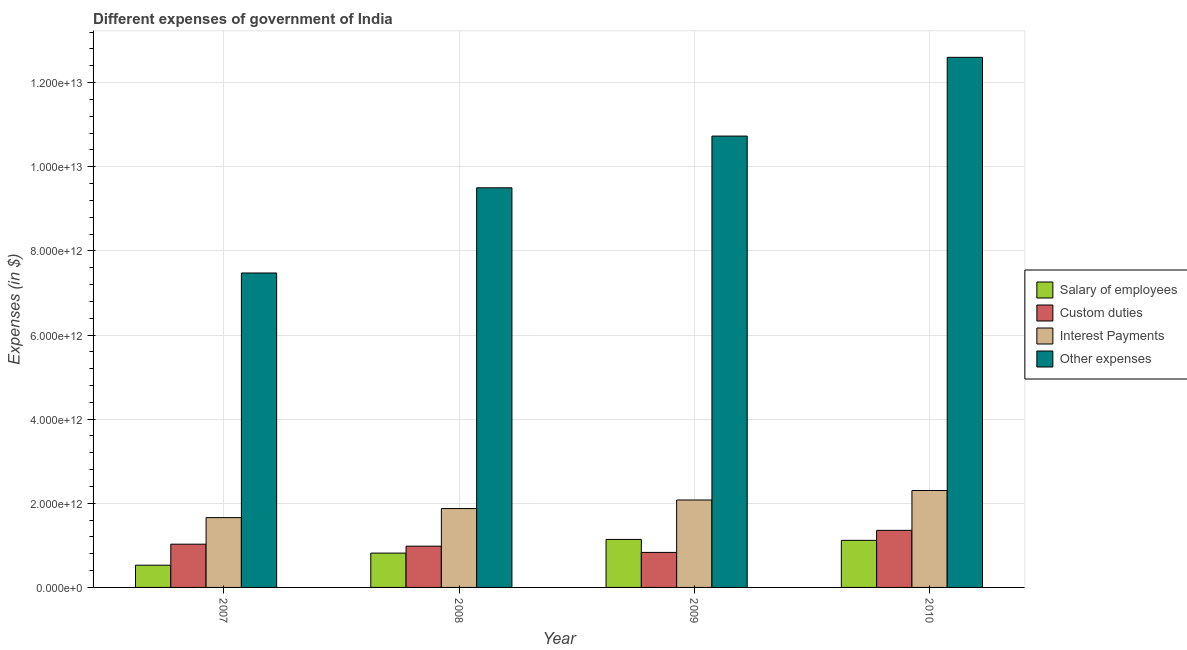How many different coloured bars are there?
Offer a very short reply. 4. How many groups of bars are there?
Your response must be concise. 4. How many bars are there on the 1st tick from the right?
Keep it short and to the point. 4. What is the label of the 4th group of bars from the left?
Provide a short and direct response. 2010. What is the amount spent on salary of employees in 2007?
Ensure brevity in your answer.  5.28e+11. Across all years, what is the maximum amount spent on other expenses?
Make the answer very short. 1.26e+13. Across all years, what is the minimum amount spent on salary of employees?
Your answer should be compact. 5.28e+11. In which year was the amount spent on salary of employees maximum?
Give a very brief answer. 2009. What is the total amount spent on other expenses in the graph?
Offer a terse response. 4.03e+13. What is the difference between the amount spent on interest payments in 2007 and that in 2008?
Offer a terse response. -2.15e+11. What is the difference between the amount spent on other expenses in 2008 and the amount spent on interest payments in 2009?
Provide a short and direct response. -1.23e+12. What is the average amount spent on salary of employees per year?
Offer a very short reply. 9.01e+11. In how many years, is the amount spent on interest payments greater than 7600000000000 $?
Offer a terse response. 0. What is the ratio of the amount spent on other expenses in 2007 to that in 2009?
Provide a short and direct response. 0.7. Is the difference between the amount spent on salary of employees in 2008 and 2009 greater than the difference between the amount spent on custom duties in 2008 and 2009?
Offer a very short reply. No. What is the difference between the highest and the second highest amount spent on other expenses?
Keep it short and to the point. 1.87e+12. What is the difference between the highest and the lowest amount spent on interest payments?
Offer a very short reply. 6.44e+11. In how many years, is the amount spent on custom duties greater than the average amount spent on custom duties taken over all years?
Keep it short and to the point. 1. Is it the case that in every year, the sum of the amount spent on interest payments and amount spent on other expenses is greater than the sum of amount spent on salary of employees and amount spent on custom duties?
Ensure brevity in your answer.  Yes. What does the 4th bar from the left in 2007 represents?
Your answer should be compact. Other expenses. What does the 1st bar from the right in 2009 represents?
Keep it short and to the point. Other expenses. Is it the case that in every year, the sum of the amount spent on salary of employees and amount spent on custom duties is greater than the amount spent on interest payments?
Your answer should be very brief. No. Are all the bars in the graph horizontal?
Provide a short and direct response. No. How many years are there in the graph?
Ensure brevity in your answer.  4. What is the difference between two consecutive major ticks on the Y-axis?
Provide a succinct answer. 2.00e+12. What is the title of the graph?
Provide a short and direct response. Different expenses of government of India. Does "Third 20% of population" appear as one of the legend labels in the graph?
Your answer should be very brief. No. What is the label or title of the Y-axis?
Give a very brief answer. Expenses (in $). What is the Expenses (in $) of Salary of employees in 2007?
Ensure brevity in your answer.  5.28e+11. What is the Expenses (in $) of Custom duties in 2007?
Your answer should be very brief. 1.03e+12. What is the Expenses (in $) in Interest Payments in 2007?
Offer a very short reply. 1.66e+12. What is the Expenses (in $) in Other expenses in 2007?
Offer a terse response. 7.47e+12. What is the Expenses (in $) of Salary of employees in 2008?
Give a very brief answer. 8.16e+11. What is the Expenses (in $) in Custom duties in 2008?
Offer a very short reply. 9.81e+11. What is the Expenses (in $) of Interest Payments in 2008?
Keep it short and to the point. 1.87e+12. What is the Expenses (in $) of Other expenses in 2008?
Provide a short and direct response. 9.50e+12. What is the Expenses (in $) of Salary of employees in 2009?
Your answer should be compact. 1.14e+12. What is the Expenses (in $) of Custom duties in 2009?
Make the answer very short. 8.32e+11. What is the Expenses (in $) in Interest Payments in 2009?
Your answer should be compact. 2.08e+12. What is the Expenses (in $) of Other expenses in 2009?
Make the answer very short. 1.07e+13. What is the Expenses (in $) in Salary of employees in 2010?
Provide a succinct answer. 1.12e+12. What is the Expenses (in $) in Custom duties in 2010?
Offer a very short reply. 1.36e+12. What is the Expenses (in $) of Interest Payments in 2010?
Ensure brevity in your answer.  2.30e+12. What is the Expenses (in $) in Other expenses in 2010?
Ensure brevity in your answer.  1.26e+13. Across all years, what is the maximum Expenses (in $) of Salary of employees?
Offer a very short reply. 1.14e+12. Across all years, what is the maximum Expenses (in $) of Custom duties?
Your answer should be very brief. 1.36e+12. Across all years, what is the maximum Expenses (in $) in Interest Payments?
Make the answer very short. 2.30e+12. Across all years, what is the maximum Expenses (in $) in Other expenses?
Your answer should be compact. 1.26e+13. Across all years, what is the minimum Expenses (in $) of Salary of employees?
Provide a succinct answer. 5.28e+11. Across all years, what is the minimum Expenses (in $) in Custom duties?
Offer a very short reply. 8.32e+11. Across all years, what is the minimum Expenses (in $) in Interest Payments?
Your answer should be compact. 1.66e+12. Across all years, what is the minimum Expenses (in $) of Other expenses?
Ensure brevity in your answer.  7.47e+12. What is the total Expenses (in $) of Salary of employees in the graph?
Provide a succinct answer. 3.60e+12. What is the total Expenses (in $) of Custom duties in the graph?
Provide a succinct answer. 4.20e+12. What is the total Expenses (in $) of Interest Payments in the graph?
Give a very brief answer. 7.92e+12. What is the total Expenses (in $) in Other expenses in the graph?
Offer a very short reply. 4.03e+13. What is the difference between the Expenses (in $) of Salary of employees in 2007 and that in 2008?
Provide a short and direct response. -2.88e+11. What is the difference between the Expenses (in $) of Custom duties in 2007 and that in 2008?
Your response must be concise. 4.70e+1. What is the difference between the Expenses (in $) in Interest Payments in 2007 and that in 2008?
Offer a very short reply. -2.15e+11. What is the difference between the Expenses (in $) of Other expenses in 2007 and that in 2008?
Keep it short and to the point. -2.03e+12. What is the difference between the Expenses (in $) of Salary of employees in 2007 and that in 2009?
Offer a terse response. -6.13e+11. What is the difference between the Expenses (in $) in Custom duties in 2007 and that in 2009?
Your answer should be very brief. 1.96e+11. What is the difference between the Expenses (in $) of Interest Payments in 2007 and that in 2009?
Provide a succinct answer. -4.19e+11. What is the difference between the Expenses (in $) in Other expenses in 2007 and that in 2009?
Your response must be concise. -3.25e+12. What is the difference between the Expenses (in $) in Salary of employees in 2007 and that in 2010?
Give a very brief answer. -5.91e+11. What is the difference between the Expenses (in $) in Custom duties in 2007 and that in 2010?
Give a very brief answer. -3.29e+11. What is the difference between the Expenses (in $) of Interest Payments in 2007 and that in 2010?
Offer a very short reply. -6.44e+11. What is the difference between the Expenses (in $) in Other expenses in 2007 and that in 2010?
Your response must be concise. -5.13e+12. What is the difference between the Expenses (in $) of Salary of employees in 2008 and that in 2009?
Your answer should be very brief. -3.25e+11. What is the difference between the Expenses (in $) in Custom duties in 2008 and that in 2009?
Keep it short and to the point. 1.49e+11. What is the difference between the Expenses (in $) of Interest Payments in 2008 and that in 2009?
Make the answer very short. -2.04e+11. What is the difference between the Expenses (in $) in Other expenses in 2008 and that in 2009?
Offer a terse response. -1.23e+12. What is the difference between the Expenses (in $) in Salary of employees in 2008 and that in 2010?
Make the answer very short. -3.03e+11. What is the difference between the Expenses (in $) of Custom duties in 2008 and that in 2010?
Provide a short and direct response. -3.76e+11. What is the difference between the Expenses (in $) of Interest Payments in 2008 and that in 2010?
Give a very brief answer. -4.29e+11. What is the difference between the Expenses (in $) in Other expenses in 2008 and that in 2010?
Keep it short and to the point. -3.10e+12. What is the difference between the Expenses (in $) in Salary of employees in 2009 and that in 2010?
Make the answer very short. 2.18e+1. What is the difference between the Expenses (in $) in Custom duties in 2009 and that in 2010?
Your response must be concise. -5.24e+11. What is the difference between the Expenses (in $) in Interest Payments in 2009 and that in 2010?
Ensure brevity in your answer.  -2.25e+11. What is the difference between the Expenses (in $) of Other expenses in 2009 and that in 2010?
Offer a terse response. -1.87e+12. What is the difference between the Expenses (in $) in Salary of employees in 2007 and the Expenses (in $) in Custom duties in 2008?
Your answer should be compact. -4.53e+11. What is the difference between the Expenses (in $) in Salary of employees in 2007 and the Expenses (in $) in Interest Payments in 2008?
Your answer should be very brief. -1.35e+12. What is the difference between the Expenses (in $) in Salary of employees in 2007 and the Expenses (in $) in Other expenses in 2008?
Give a very brief answer. -8.97e+12. What is the difference between the Expenses (in $) in Custom duties in 2007 and the Expenses (in $) in Interest Payments in 2008?
Your response must be concise. -8.47e+11. What is the difference between the Expenses (in $) of Custom duties in 2007 and the Expenses (in $) of Other expenses in 2008?
Ensure brevity in your answer.  -8.47e+12. What is the difference between the Expenses (in $) in Interest Payments in 2007 and the Expenses (in $) in Other expenses in 2008?
Provide a succinct answer. -7.84e+12. What is the difference between the Expenses (in $) in Salary of employees in 2007 and the Expenses (in $) in Custom duties in 2009?
Provide a short and direct response. -3.04e+11. What is the difference between the Expenses (in $) of Salary of employees in 2007 and the Expenses (in $) of Interest Payments in 2009?
Provide a short and direct response. -1.55e+12. What is the difference between the Expenses (in $) in Salary of employees in 2007 and the Expenses (in $) in Other expenses in 2009?
Provide a succinct answer. -1.02e+13. What is the difference between the Expenses (in $) of Custom duties in 2007 and the Expenses (in $) of Interest Payments in 2009?
Your answer should be compact. -1.05e+12. What is the difference between the Expenses (in $) of Custom duties in 2007 and the Expenses (in $) of Other expenses in 2009?
Give a very brief answer. -9.70e+12. What is the difference between the Expenses (in $) of Interest Payments in 2007 and the Expenses (in $) of Other expenses in 2009?
Provide a short and direct response. -9.07e+12. What is the difference between the Expenses (in $) of Salary of employees in 2007 and the Expenses (in $) of Custom duties in 2010?
Your response must be concise. -8.28e+11. What is the difference between the Expenses (in $) in Salary of employees in 2007 and the Expenses (in $) in Interest Payments in 2010?
Your answer should be compact. -1.78e+12. What is the difference between the Expenses (in $) of Salary of employees in 2007 and the Expenses (in $) of Other expenses in 2010?
Keep it short and to the point. -1.21e+13. What is the difference between the Expenses (in $) in Custom duties in 2007 and the Expenses (in $) in Interest Payments in 2010?
Provide a succinct answer. -1.28e+12. What is the difference between the Expenses (in $) of Custom duties in 2007 and the Expenses (in $) of Other expenses in 2010?
Keep it short and to the point. -1.16e+13. What is the difference between the Expenses (in $) of Interest Payments in 2007 and the Expenses (in $) of Other expenses in 2010?
Make the answer very short. -1.09e+13. What is the difference between the Expenses (in $) of Salary of employees in 2008 and the Expenses (in $) of Custom duties in 2009?
Ensure brevity in your answer.  -1.65e+1. What is the difference between the Expenses (in $) in Salary of employees in 2008 and the Expenses (in $) in Interest Payments in 2009?
Ensure brevity in your answer.  -1.26e+12. What is the difference between the Expenses (in $) of Salary of employees in 2008 and the Expenses (in $) of Other expenses in 2009?
Your answer should be compact. -9.91e+12. What is the difference between the Expenses (in $) of Custom duties in 2008 and the Expenses (in $) of Interest Payments in 2009?
Provide a succinct answer. -1.10e+12. What is the difference between the Expenses (in $) of Custom duties in 2008 and the Expenses (in $) of Other expenses in 2009?
Give a very brief answer. -9.75e+12. What is the difference between the Expenses (in $) of Interest Payments in 2008 and the Expenses (in $) of Other expenses in 2009?
Give a very brief answer. -8.85e+12. What is the difference between the Expenses (in $) in Salary of employees in 2008 and the Expenses (in $) in Custom duties in 2010?
Your answer should be very brief. -5.41e+11. What is the difference between the Expenses (in $) in Salary of employees in 2008 and the Expenses (in $) in Interest Payments in 2010?
Your answer should be very brief. -1.49e+12. What is the difference between the Expenses (in $) in Salary of employees in 2008 and the Expenses (in $) in Other expenses in 2010?
Ensure brevity in your answer.  -1.18e+13. What is the difference between the Expenses (in $) in Custom duties in 2008 and the Expenses (in $) in Interest Payments in 2010?
Make the answer very short. -1.32e+12. What is the difference between the Expenses (in $) in Custom duties in 2008 and the Expenses (in $) in Other expenses in 2010?
Ensure brevity in your answer.  -1.16e+13. What is the difference between the Expenses (in $) in Interest Payments in 2008 and the Expenses (in $) in Other expenses in 2010?
Ensure brevity in your answer.  -1.07e+13. What is the difference between the Expenses (in $) in Salary of employees in 2009 and the Expenses (in $) in Custom duties in 2010?
Provide a succinct answer. -2.16e+11. What is the difference between the Expenses (in $) of Salary of employees in 2009 and the Expenses (in $) of Interest Payments in 2010?
Give a very brief answer. -1.16e+12. What is the difference between the Expenses (in $) of Salary of employees in 2009 and the Expenses (in $) of Other expenses in 2010?
Your response must be concise. -1.15e+13. What is the difference between the Expenses (in $) of Custom duties in 2009 and the Expenses (in $) of Interest Payments in 2010?
Provide a short and direct response. -1.47e+12. What is the difference between the Expenses (in $) of Custom duties in 2009 and the Expenses (in $) of Other expenses in 2010?
Offer a terse response. -1.18e+13. What is the difference between the Expenses (in $) of Interest Payments in 2009 and the Expenses (in $) of Other expenses in 2010?
Your response must be concise. -1.05e+13. What is the average Expenses (in $) in Salary of employees per year?
Keep it short and to the point. 9.01e+11. What is the average Expenses (in $) of Custom duties per year?
Your answer should be compact. 1.05e+12. What is the average Expenses (in $) in Interest Payments per year?
Provide a succinct answer. 1.98e+12. What is the average Expenses (in $) in Other expenses per year?
Provide a short and direct response. 1.01e+13. In the year 2007, what is the difference between the Expenses (in $) of Salary of employees and Expenses (in $) of Custom duties?
Your answer should be very brief. -5.00e+11. In the year 2007, what is the difference between the Expenses (in $) in Salary of employees and Expenses (in $) in Interest Payments?
Your answer should be very brief. -1.13e+12. In the year 2007, what is the difference between the Expenses (in $) of Salary of employees and Expenses (in $) of Other expenses?
Your response must be concise. -6.95e+12. In the year 2007, what is the difference between the Expenses (in $) in Custom duties and Expenses (in $) in Interest Payments?
Your answer should be very brief. -6.31e+11. In the year 2007, what is the difference between the Expenses (in $) of Custom duties and Expenses (in $) of Other expenses?
Ensure brevity in your answer.  -6.45e+12. In the year 2007, what is the difference between the Expenses (in $) in Interest Payments and Expenses (in $) in Other expenses?
Your response must be concise. -5.81e+12. In the year 2008, what is the difference between the Expenses (in $) of Salary of employees and Expenses (in $) of Custom duties?
Make the answer very short. -1.65e+11. In the year 2008, what is the difference between the Expenses (in $) of Salary of employees and Expenses (in $) of Interest Payments?
Your answer should be compact. -1.06e+12. In the year 2008, what is the difference between the Expenses (in $) of Salary of employees and Expenses (in $) of Other expenses?
Ensure brevity in your answer.  -8.68e+12. In the year 2008, what is the difference between the Expenses (in $) of Custom duties and Expenses (in $) of Interest Payments?
Make the answer very short. -8.94e+11. In the year 2008, what is the difference between the Expenses (in $) in Custom duties and Expenses (in $) in Other expenses?
Your answer should be compact. -8.52e+12. In the year 2008, what is the difference between the Expenses (in $) in Interest Payments and Expenses (in $) in Other expenses?
Ensure brevity in your answer.  -7.62e+12. In the year 2009, what is the difference between the Expenses (in $) in Salary of employees and Expenses (in $) in Custom duties?
Offer a very short reply. 3.08e+11. In the year 2009, what is the difference between the Expenses (in $) of Salary of employees and Expenses (in $) of Interest Payments?
Make the answer very short. -9.37e+11. In the year 2009, what is the difference between the Expenses (in $) in Salary of employees and Expenses (in $) in Other expenses?
Keep it short and to the point. -9.59e+12. In the year 2009, what is the difference between the Expenses (in $) in Custom duties and Expenses (in $) in Interest Payments?
Provide a succinct answer. -1.25e+12. In the year 2009, what is the difference between the Expenses (in $) of Custom duties and Expenses (in $) of Other expenses?
Offer a very short reply. -9.90e+12. In the year 2009, what is the difference between the Expenses (in $) in Interest Payments and Expenses (in $) in Other expenses?
Offer a terse response. -8.65e+12. In the year 2010, what is the difference between the Expenses (in $) in Salary of employees and Expenses (in $) in Custom duties?
Your response must be concise. -2.38e+11. In the year 2010, what is the difference between the Expenses (in $) of Salary of employees and Expenses (in $) of Interest Payments?
Your answer should be very brief. -1.18e+12. In the year 2010, what is the difference between the Expenses (in $) in Salary of employees and Expenses (in $) in Other expenses?
Your response must be concise. -1.15e+13. In the year 2010, what is the difference between the Expenses (in $) in Custom duties and Expenses (in $) in Interest Payments?
Your answer should be very brief. -9.47e+11. In the year 2010, what is the difference between the Expenses (in $) in Custom duties and Expenses (in $) in Other expenses?
Your answer should be compact. -1.12e+13. In the year 2010, what is the difference between the Expenses (in $) in Interest Payments and Expenses (in $) in Other expenses?
Offer a very short reply. -1.03e+13. What is the ratio of the Expenses (in $) of Salary of employees in 2007 to that in 2008?
Your answer should be very brief. 0.65. What is the ratio of the Expenses (in $) in Custom duties in 2007 to that in 2008?
Give a very brief answer. 1.05. What is the ratio of the Expenses (in $) of Interest Payments in 2007 to that in 2008?
Give a very brief answer. 0.89. What is the ratio of the Expenses (in $) in Other expenses in 2007 to that in 2008?
Your answer should be compact. 0.79. What is the ratio of the Expenses (in $) of Salary of employees in 2007 to that in 2009?
Your answer should be very brief. 0.46. What is the ratio of the Expenses (in $) in Custom duties in 2007 to that in 2009?
Make the answer very short. 1.23. What is the ratio of the Expenses (in $) of Interest Payments in 2007 to that in 2009?
Provide a short and direct response. 0.8. What is the ratio of the Expenses (in $) in Other expenses in 2007 to that in 2009?
Your answer should be very brief. 0.7. What is the ratio of the Expenses (in $) in Salary of employees in 2007 to that in 2010?
Provide a short and direct response. 0.47. What is the ratio of the Expenses (in $) of Custom duties in 2007 to that in 2010?
Offer a terse response. 0.76. What is the ratio of the Expenses (in $) in Interest Payments in 2007 to that in 2010?
Give a very brief answer. 0.72. What is the ratio of the Expenses (in $) of Other expenses in 2007 to that in 2010?
Keep it short and to the point. 0.59. What is the ratio of the Expenses (in $) in Salary of employees in 2008 to that in 2009?
Give a very brief answer. 0.72. What is the ratio of the Expenses (in $) of Custom duties in 2008 to that in 2009?
Keep it short and to the point. 1.18. What is the ratio of the Expenses (in $) in Interest Payments in 2008 to that in 2009?
Offer a very short reply. 0.9. What is the ratio of the Expenses (in $) in Other expenses in 2008 to that in 2009?
Offer a terse response. 0.89. What is the ratio of the Expenses (in $) in Salary of employees in 2008 to that in 2010?
Offer a very short reply. 0.73. What is the ratio of the Expenses (in $) of Custom duties in 2008 to that in 2010?
Your answer should be very brief. 0.72. What is the ratio of the Expenses (in $) of Interest Payments in 2008 to that in 2010?
Offer a terse response. 0.81. What is the ratio of the Expenses (in $) of Other expenses in 2008 to that in 2010?
Make the answer very short. 0.75. What is the ratio of the Expenses (in $) of Salary of employees in 2009 to that in 2010?
Offer a terse response. 1.02. What is the ratio of the Expenses (in $) in Custom duties in 2009 to that in 2010?
Your response must be concise. 0.61. What is the ratio of the Expenses (in $) in Interest Payments in 2009 to that in 2010?
Make the answer very short. 0.9. What is the ratio of the Expenses (in $) of Other expenses in 2009 to that in 2010?
Your answer should be very brief. 0.85. What is the difference between the highest and the second highest Expenses (in $) in Salary of employees?
Your answer should be compact. 2.18e+1. What is the difference between the highest and the second highest Expenses (in $) in Custom duties?
Your response must be concise. 3.29e+11. What is the difference between the highest and the second highest Expenses (in $) in Interest Payments?
Make the answer very short. 2.25e+11. What is the difference between the highest and the second highest Expenses (in $) of Other expenses?
Provide a succinct answer. 1.87e+12. What is the difference between the highest and the lowest Expenses (in $) of Salary of employees?
Offer a very short reply. 6.13e+11. What is the difference between the highest and the lowest Expenses (in $) of Custom duties?
Make the answer very short. 5.24e+11. What is the difference between the highest and the lowest Expenses (in $) in Interest Payments?
Make the answer very short. 6.44e+11. What is the difference between the highest and the lowest Expenses (in $) of Other expenses?
Provide a short and direct response. 5.13e+12. 